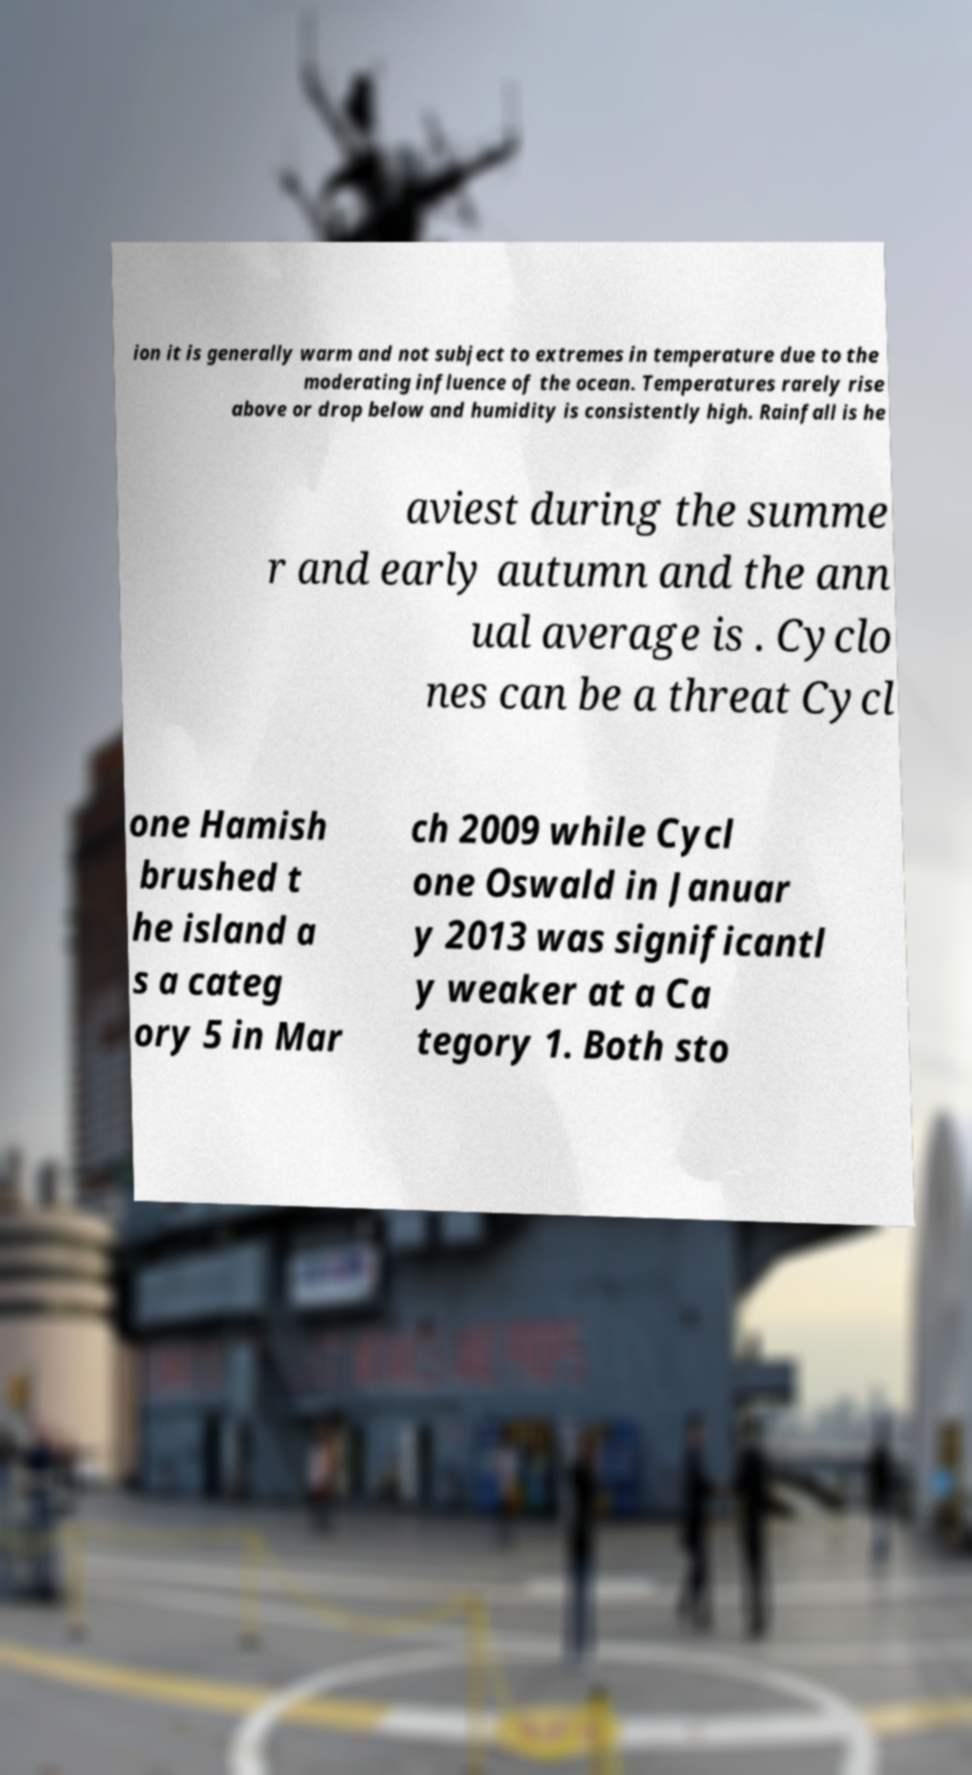Please read and relay the text visible in this image. What does it say? ion it is generally warm and not subject to extremes in temperature due to the moderating influence of the ocean. Temperatures rarely rise above or drop below and humidity is consistently high. Rainfall is he aviest during the summe r and early autumn and the ann ual average is . Cyclo nes can be a threat Cycl one Hamish brushed t he island a s a categ ory 5 in Mar ch 2009 while Cycl one Oswald in Januar y 2013 was significantl y weaker at a Ca tegory 1. Both sto 